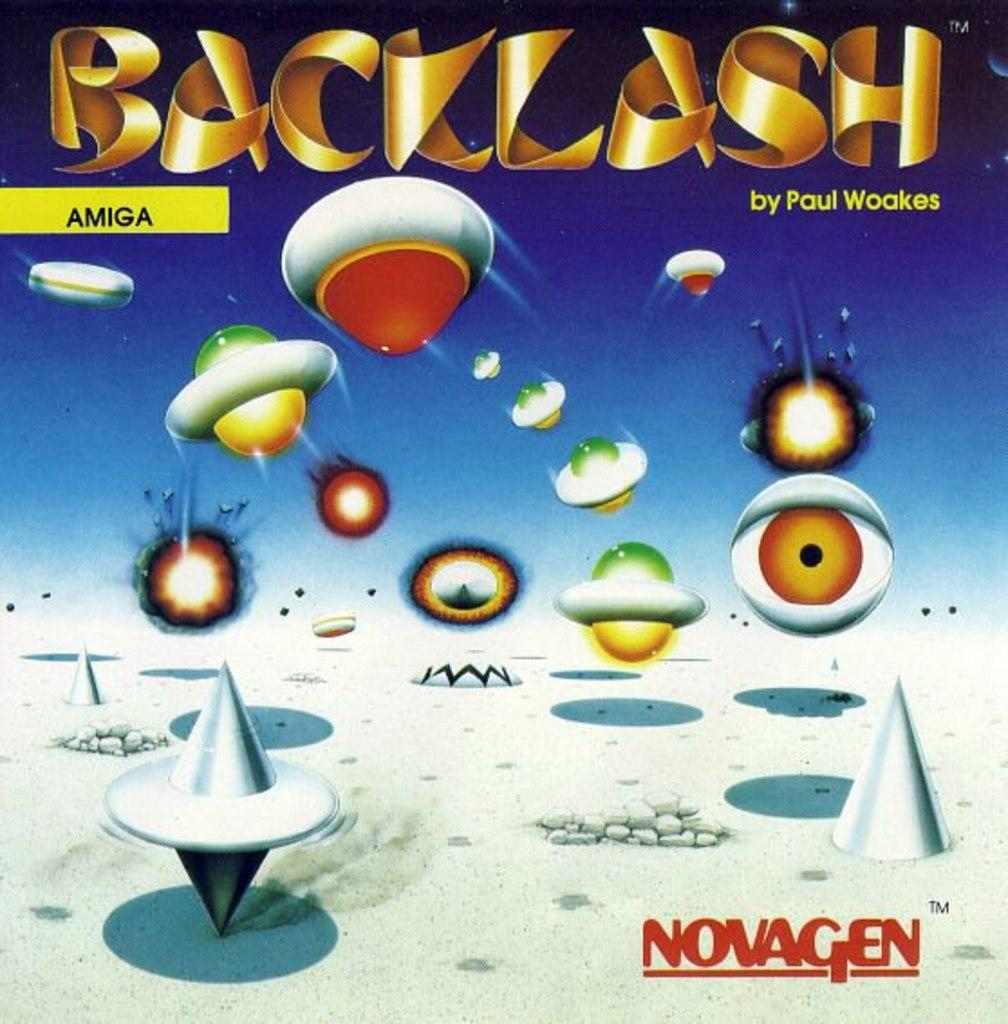What objects are located in the middle of the image? There are toys in the middle of the image. What can be seen at the top of the image? There is text at the top of the image. What is depicted on the right side of the image? There is an eye on the right side of the image. What type of media is the image? The image is an animation. What type of curtain is hanging in the image? There is no curtain present in the image. What rule is being enforced in the image? There is no rule being enforced in the image; it is an animation featuring toys, text, and an eye. 